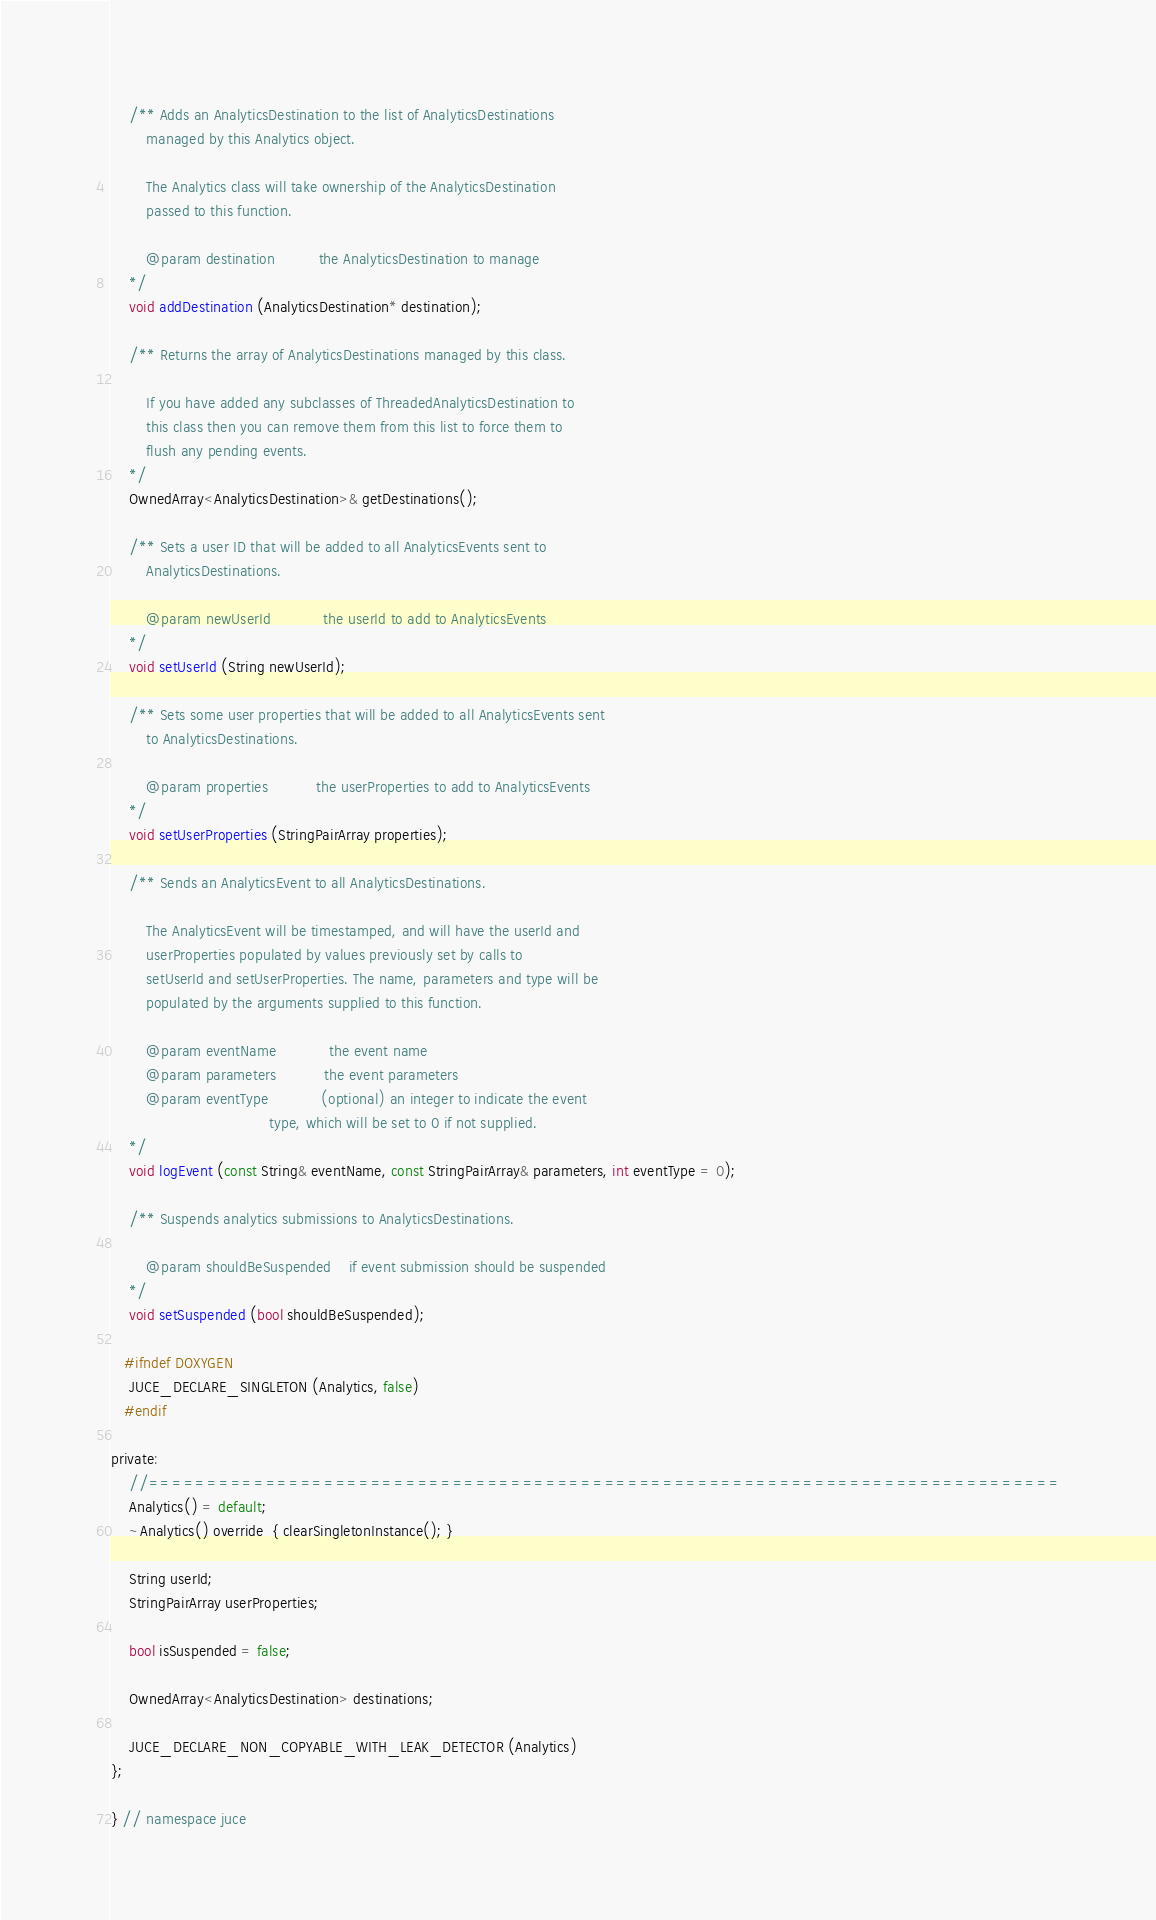<code> <loc_0><loc_0><loc_500><loc_500><_C_>    /** Adds an AnalyticsDestination to the list of AnalyticsDestinations
        managed by this Analytics object.

        The Analytics class will take ownership of the AnalyticsDestination
        passed to this function.

        @param destination          the AnalyticsDestination to manage
    */
    void addDestination (AnalyticsDestination* destination);

    /** Returns the array of AnalyticsDestinations managed by this class.

        If you have added any subclasses of ThreadedAnalyticsDestination to
        this class then you can remove them from this list to force them to
        flush any pending events.
    */
    OwnedArray<AnalyticsDestination>& getDestinations();

    /** Sets a user ID that will be added to all AnalyticsEvents sent to
        AnalyticsDestinations.

        @param newUserId            the userId to add to AnalyticsEvents
    */
    void setUserId (String newUserId);

    /** Sets some user properties that will be added to all AnalyticsEvents sent
        to AnalyticsDestinations.

        @param properties           the userProperties to add to AnalyticsEvents
    */
    void setUserProperties (StringPairArray properties);

    /** Sends an AnalyticsEvent to all AnalyticsDestinations.

        The AnalyticsEvent will be timestamped, and will have the userId and
        userProperties populated by values previously set by calls to
        setUserId and setUserProperties. The name, parameters and type will be
        populated by the arguments supplied to this function.

        @param eventName            the event name
        @param parameters           the event parameters
        @param eventType            (optional) an integer to indicate the event
                                    type, which will be set to 0 if not supplied.
    */
    void logEvent (const String& eventName, const StringPairArray& parameters, int eventType = 0);

    /** Suspends analytics submissions to AnalyticsDestinations.

        @param shouldBeSuspended    if event submission should be suspended
    */
    void setSuspended (bool shouldBeSuspended);

   #ifndef DOXYGEN
    JUCE_DECLARE_SINGLETON (Analytics, false)
   #endif

private:
    //==============================================================================
    Analytics() = default;
    ~Analytics() override  { clearSingletonInstance(); }

    String userId;
    StringPairArray userProperties;

    bool isSuspended = false;

    OwnedArray<AnalyticsDestination> destinations;

    JUCE_DECLARE_NON_COPYABLE_WITH_LEAK_DETECTOR (Analytics)
};

} // namespace juce
</code> 